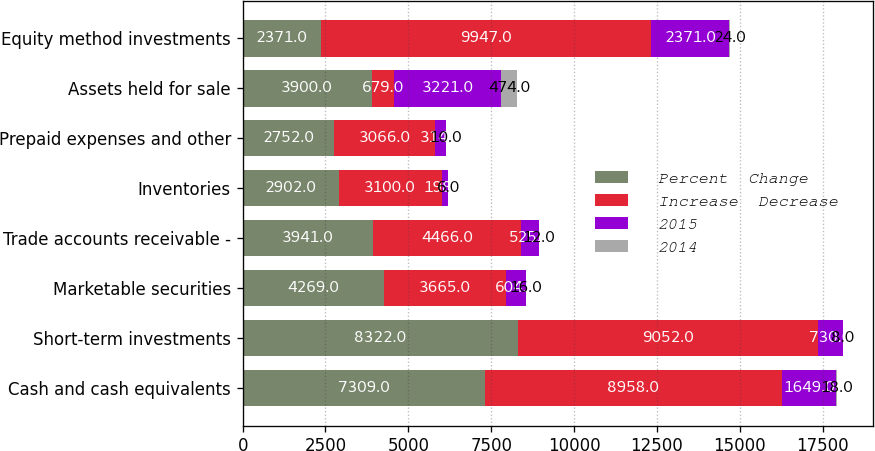Convert chart to OTSL. <chart><loc_0><loc_0><loc_500><loc_500><stacked_bar_chart><ecel><fcel>Cash and cash equivalents<fcel>Short-term investments<fcel>Marketable securities<fcel>Trade accounts receivable -<fcel>Inventories<fcel>Prepaid expenses and other<fcel>Assets held for sale<fcel>Equity method investments<nl><fcel>Percent  Change<fcel>7309<fcel>8322<fcel>4269<fcel>3941<fcel>2902<fcel>2752<fcel>3900<fcel>2371<nl><fcel>Increase  Decrease<fcel>8958<fcel>9052<fcel>3665<fcel>4466<fcel>3100<fcel>3066<fcel>679<fcel>9947<nl><fcel>2015<fcel>1649<fcel>730<fcel>604<fcel>525<fcel>198<fcel>314<fcel>3221<fcel>2371<nl><fcel>2014<fcel>18<fcel>8<fcel>16<fcel>12<fcel>6<fcel>10<fcel>474<fcel>24<nl></chart> 